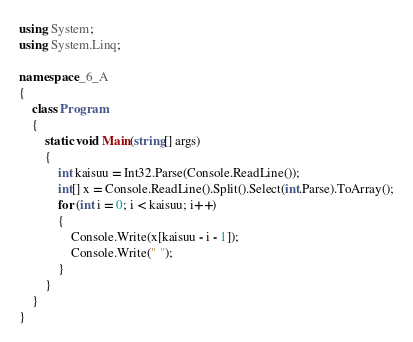<code> <loc_0><loc_0><loc_500><loc_500><_C#_>using System;
using System.Linq;

namespace _6_A
{
    class Program
    {
        static void Main(string[] args)
        {
            int kaisuu = Int32.Parse(Console.ReadLine());
            int[] x = Console.ReadLine().Split().Select(int.Parse).ToArray();
            for (int i = 0; i < kaisuu; i++)
            {
                Console.Write(x[kaisuu - i - 1]);
                Console.Write(" ");
            }
        }
    }
}</code> 